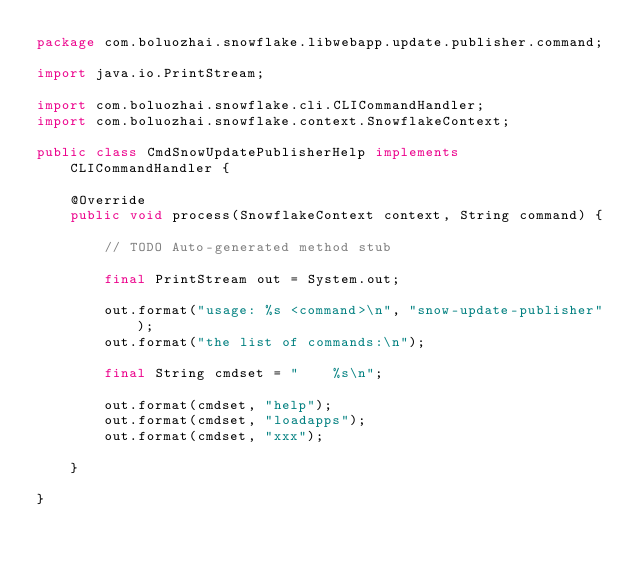<code> <loc_0><loc_0><loc_500><loc_500><_Java_>package com.boluozhai.snowflake.libwebapp.update.publisher.command;

import java.io.PrintStream;

import com.boluozhai.snowflake.cli.CLICommandHandler;
import com.boluozhai.snowflake.context.SnowflakeContext;

public class CmdSnowUpdatePublisherHelp implements CLICommandHandler {

	@Override
	public void process(SnowflakeContext context, String command) {

		// TODO Auto-generated method stub

		final PrintStream out = System.out;

		out.format("usage: %s <command>\n", "snow-update-publisher");
		out.format("the list of commands:\n");

		final String cmdset = "    %s\n";

		out.format(cmdset, "help");
		out.format(cmdset, "loadapps");
		out.format(cmdset, "xxx");

	}

}
</code> 